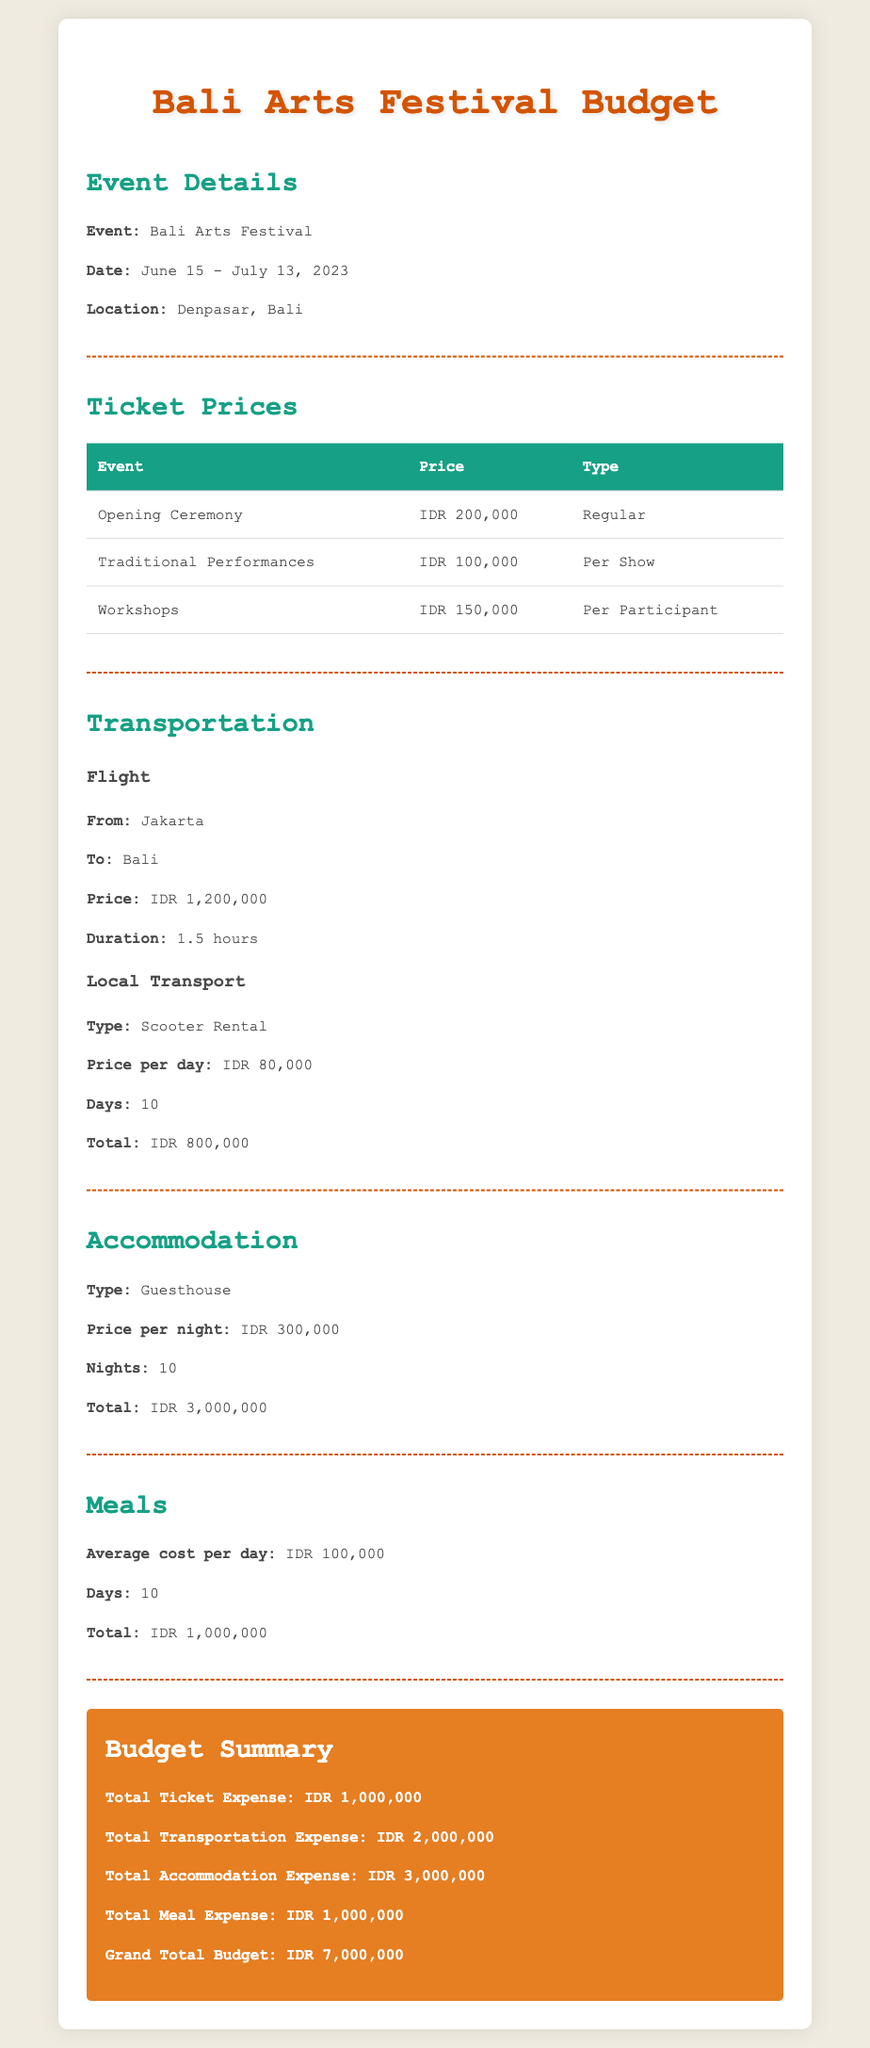What is the event? The document describes a budget for attending a specific event, which is clearly indicated at the beginning.
Answer: Bali Arts Festival What are the dates of the festival? The dates of the event are provided in the document, detailing when it takes place.
Answer: June 15 - July 13, 2023 What is the price of the Opening Ceremony ticket? The ticket prices are outlined in a table, showing the cost of each event.
Answer: IDR 200,000 What is the total accommodation expense? The total expense for accommodation is summed up in the budget summary section.
Answer: IDR 3,000,000 How much does a scooter rental cost per day? The local transport costs are specified, including the price for scooter rental.
Answer: IDR 80,000 How many nights will accommodation be booked? The document states the number of nights for the accommodation expenses.
Answer: 10 What is the average cost of meals per day? The meals section provides details on the average daily cost of meals during the event.
Answer: IDR 100,000 What is the grand total budget? The grand total budget is stated in the summary, reflecting all combined expenses.
Answer: IDR 7,000,000 What type of accommodation is mentioned? The document specifies the type of accommodation arranged for the trip.
Answer: Guesthouse 